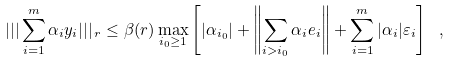Convert formula to latex. <formula><loc_0><loc_0><loc_500><loc_500>| | | \sum _ { i = 1 } ^ { m } \alpha _ { i } y _ { i } | | | _ { \, r } \leq \beta ( r ) \max _ { i _ { 0 } \geq 1 } \left [ | \alpha _ { i _ { 0 } } | + \left \| \sum _ { i > i _ { 0 } } \alpha _ { i } e _ { i } \right \| + \sum _ { i = 1 } ^ { m } | \alpha _ { i } | \varepsilon _ { i } \right ] \ ,</formula> 